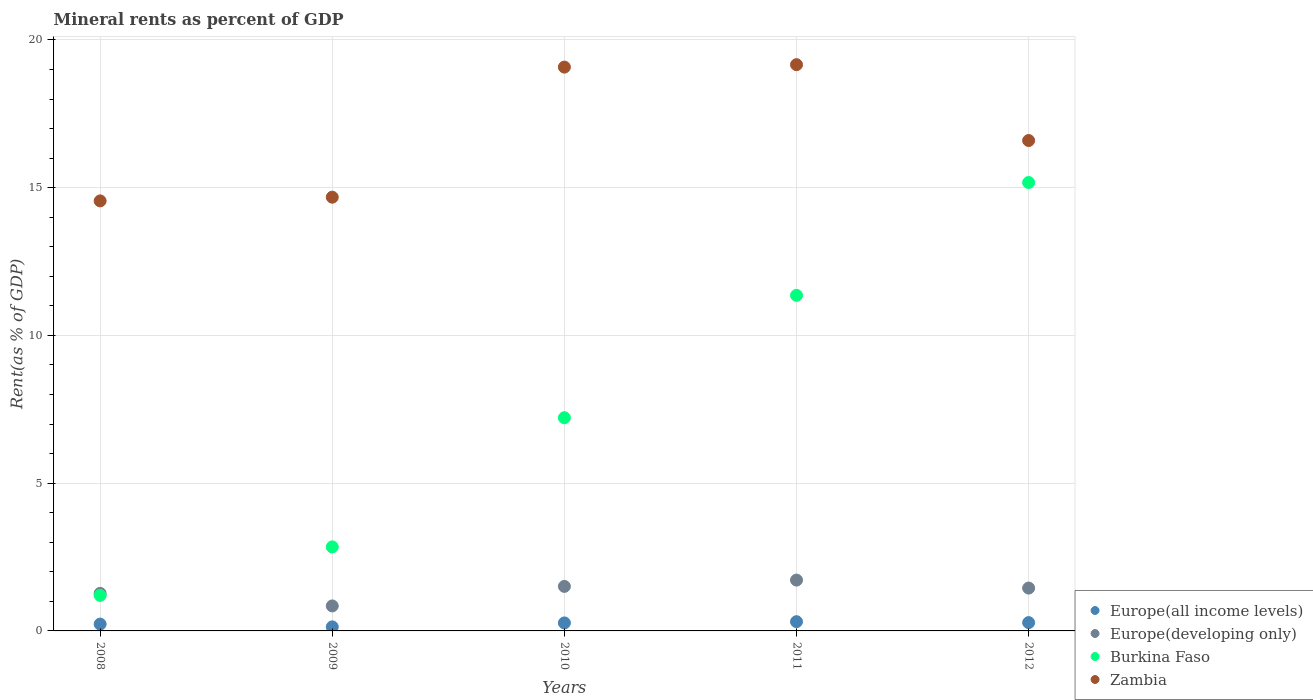How many different coloured dotlines are there?
Offer a very short reply. 4. Is the number of dotlines equal to the number of legend labels?
Make the answer very short. Yes. What is the mineral rent in Europe(all income levels) in 2012?
Ensure brevity in your answer.  0.28. Across all years, what is the maximum mineral rent in Europe(all income levels)?
Give a very brief answer. 0.31. Across all years, what is the minimum mineral rent in Zambia?
Keep it short and to the point. 14.55. What is the total mineral rent in Burkina Faso in the graph?
Provide a short and direct response. 37.79. What is the difference between the mineral rent in Europe(all income levels) in 2009 and that in 2011?
Provide a short and direct response. -0.17. What is the difference between the mineral rent in Europe(developing only) in 2012 and the mineral rent in Zambia in 2008?
Offer a terse response. -13.1. What is the average mineral rent in Zambia per year?
Give a very brief answer. 16.81. In the year 2010, what is the difference between the mineral rent in Europe(all income levels) and mineral rent in Burkina Faso?
Provide a short and direct response. -6.94. What is the ratio of the mineral rent in Europe(all income levels) in 2008 to that in 2010?
Provide a short and direct response. 0.86. Is the difference between the mineral rent in Europe(all income levels) in 2008 and 2012 greater than the difference between the mineral rent in Burkina Faso in 2008 and 2012?
Provide a succinct answer. Yes. What is the difference between the highest and the second highest mineral rent in Zambia?
Offer a very short reply. 0.08. What is the difference between the highest and the lowest mineral rent in Burkina Faso?
Keep it short and to the point. 13.97. Does the mineral rent in Europe(all income levels) monotonically increase over the years?
Your answer should be compact. No. Is the mineral rent in Europe(all income levels) strictly less than the mineral rent in Burkina Faso over the years?
Make the answer very short. Yes. Are the values on the major ticks of Y-axis written in scientific E-notation?
Provide a short and direct response. No. Does the graph contain any zero values?
Your answer should be very brief. No. Does the graph contain grids?
Offer a very short reply. Yes. What is the title of the graph?
Ensure brevity in your answer.  Mineral rents as percent of GDP. What is the label or title of the Y-axis?
Provide a short and direct response. Rent(as % of GDP). What is the Rent(as % of GDP) in Europe(all income levels) in 2008?
Keep it short and to the point. 0.23. What is the Rent(as % of GDP) in Europe(developing only) in 2008?
Your answer should be very brief. 1.27. What is the Rent(as % of GDP) of Burkina Faso in 2008?
Give a very brief answer. 1.2. What is the Rent(as % of GDP) in Zambia in 2008?
Your answer should be very brief. 14.55. What is the Rent(as % of GDP) of Europe(all income levels) in 2009?
Provide a succinct answer. 0.14. What is the Rent(as % of GDP) of Europe(developing only) in 2009?
Provide a succinct answer. 0.85. What is the Rent(as % of GDP) in Burkina Faso in 2009?
Your response must be concise. 2.84. What is the Rent(as % of GDP) of Zambia in 2009?
Offer a terse response. 14.68. What is the Rent(as % of GDP) in Europe(all income levels) in 2010?
Ensure brevity in your answer.  0.27. What is the Rent(as % of GDP) of Europe(developing only) in 2010?
Provide a short and direct response. 1.51. What is the Rent(as % of GDP) of Burkina Faso in 2010?
Make the answer very short. 7.22. What is the Rent(as % of GDP) in Zambia in 2010?
Offer a very short reply. 19.08. What is the Rent(as % of GDP) of Europe(all income levels) in 2011?
Your answer should be very brief. 0.31. What is the Rent(as % of GDP) of Europe(developing only) in 2011?
Offer a very short reply. 1.72. What is the Rent(as % of GDP) in Burkina Faso in 2011?
Make the answer very short. 11.36. What is the Rent(as % of GDP) of Zambia in 2011?
Provide a succinct answer. 19.16. What is the Rent(as % of GDP) in Europe(all income levels) in 2012?
Keep it short and to the point. 0.28. What is the Rent(as % of GDP) in Europe(developing only) in 2012?
Your answer should be very brief. 1.45. What is the Rent(as % of GDP) of Burkina Faso in 2012?
Offer a terse response. 15.18. What is the Rent(as % of GDP) in Zambia in 2012?
Offer a very short reply. 16.6. Across all years, what is the maximum Rent(as % of GDP) of Europe(all income levels)?
Your answer should be very brief. 0.31. Across all years, what is the maximum Rent(as % of GDP) in Europe(developing only)?
Ensure brevity in your answer.  1.72. Across all years, what is the maximum Rent(as % of GDP) of Burkina Faso?
Keep it short and to the point. 15.18. Across all years, what is the maximum Rent(as % of GDP) in Zambia?
Provide a succinct answer. 19.16. Across all years, what is the minimum Rent(as % of GDP) in Europe(all income levels)?
Offer a terse response. 0.14. Across all years, what is the minimum Rent(as % of GDP) of Europe(developing only)?
Your answer should be compact. 0.85. Across all years, what is the minimum Rent(as % of GDP) of Burkina Faso?
Provide a short and direct response. 1.2. Across all years, what is the minimum Rent(as % of GDP) of Zambia?
Provide a short and direct response. 14.55. What is the total Rent(as % of GDP) in Europe(all income levels) in the graph?
Offer a very short reply. 1.23. What is the total Rent(as % of GDP) of Europe(developing only) in the graph?
Offer a very short reply. 6.79. What is the total Rent(as % of GDP) of Burkina Faso in the graph?
Provide a succinct answer. 37.79. What is the total Rent(as % of GDP) of Zambia in the graph?
Offer a terse response. 84.07. What is the difference between the Rent(as % of GDP) of Europe(all income levels) in 2008 and that in 2009?
Keep it short and to the point. 0.09. What is the difference between the Rent(as % of GDP) of Europe(developing only) in 2008 and that in 2009?
Your response must be concise. 0.42. What is the difference between the Rent(as % of GDP) of Burkina Faso in 2008 and that in 2009?
Your answer should be compact. -1.64. What is the difference between the Rent(as % of GDP) in Zambia in 2008 and that in 2009?
Give a very brief answer. -0.13. What is the difference between the Rent(as % of GDP) of Europe(all income levels) in 2008 and that in 2010?
Offer a terse response. -0.04. What is the difference between the Rent(as % of GDP) of Europe(developing only) in 2008 and that in 2010?
Ensure brevity in your answer.  -0.24. What is the difference between the Rent(as % of GDP) of Burkina Faso in 2008 and that in 2010?
Ensure brevity in your answer.  -6.01. What is the difference between the Rent(as % of GDP) in Zambia in 2008 and that in 2010?
Offer a very short reply. -4.53. What is the difference between the Rent(as % of GDP) in Europe(all income levels) in 2008 and that in 2011?
Provide a succinct answer. -0.08. What is the difference between the Rent(as % of GDP) in Europe(developing only) in 2008 and that in 2011?
Your response must be concise. -0.45. What is the difference between the Rent(as % of GDP) of Burkina Faso in 2008 and that in 2011?
Offer a terse response. -10.15. What is the difference between the Rent(as % of GDP) of Zambia in 2008 and that in 2011?
Offer a very short reply. -4.61. What is the difference between the Rent(as % of GDP) of Europe(all income levels) in 2008 and that in 2012?
Offer a very short reply. -0.05. What is the difference between the Rent(as % of GDP) of Europe(developing only) in 2008 and that in 2012?
Ensure brevity in your answer.  -0.18. What is the difference between the Rent(as % of GDP) of Burkina Faso in 2008 and that in 2012?
Make the answer very short. -13.97. What is the difference between the Rent(as % of GDP) of Zambia in 2008 and that in 2012?
Offer a terse response. -2.04. What is the difference between the Rent(as % of GDP) in Europe(all income levels) in 2009 and that in 2010?
Offer a terse response. -0.13. What is the difference between the Rent(as % of GDP) of Europe(developing only) in 2009 and that in 2010?
Give a very brief answer. -0.66. What is the difference between the Rent(as % of GDP) of Burkina Faso in 2009 and that in 2010?
Keep it short and to the point. -4.37. What is the difference between the Rent(as % of GDP) of Zambia in 2009 and that in 2010?
Your answer should be very brief. -4.4. What is the difference between the Rent(as % of GDP) of Europe(all income levels) in 2009 and that in 2011?
Offer a very short reply. -0.17. What is the difference between the Rent(as % of GDP) in Europe(developing only) in 2009 and that in 2011?
Your response must be concise. -0.87. What is the difference between the Rent(as % of GDP) of Burkina Faso in 2009 and that in 2011?
Make the answer very short. -8.51. What is the difference between the Rent(as % of GDP) in Zambia in 2009 and that in 2011?
Keep it short and to the point. -4.48. What is the difference between the Rent(as % of GDP) of Europe(all income levels) in 2009 and that in 2012?
Keep it short and to the point. -0.14. What is the difference between the Rent(as % of GDP) of Europe(developing only) in 2009 and that in 2012?
Offer a terse response. -0.6. What is the difference between the Rent(as % of GDP) in Burkina Faso in 2009 and that in 2012?
Give a very brief answer. -12.33. What is the difference between the Rent(as % of GDP) in Zambia in 2009 and that in 2012?
Offer a terse response. -1.92. What is the difference between the Rent(as % of GDP) in Europe(all income levels) in 2010 and that in 2011?
Offer a very short reply. -0.04. What is the difference between the Rent(as % of GDP) in Europe(developing only) in 2010 and that in 2011?
Ensure brevity in your answer.  -0.21. What is the difference between the Rent(as % of GDP) of Burkina Faso in 2010 and that in 2011?
Ensure brevity in your answer.  -4.14. What is the difference between the Rent(as % of GDP) of Zambia in 2010 and that in 2011?
Your response must be concise. -0.08. What is the difference between the Rent(as % of GDP) of Europe(all income levels) in 2010 and that in 2012?
Give a very brief answer. -0.01. What is the difference between the Rent(as % of GDP) in Europe(developing only) in 2010 and that in 2012?
Your response must be concise. 0.06. What is the difference between the Rent(as % of GDP) in Burkina Faso in 2010 and that in 2012?
Provide a short and direct response. -7.96. What is the difference between the Rent(as % of GDP) of Zambia in 2010 and that in 2012?
Your response must be concise. 2.48. What is the difference between the Rent(as % of GDP) of Europe(all income levels) in 2011 and that in 2012?
Give a very brief answer. 0.03. What is the difference between the Rent(as % of GDP) in Europe(developing only) in 2011 and that in 2012?
Ensure brevity in your answer.  0.27. What is the difference between the Rent(as % of GDP) of Burkina Faso in 2011 and that in 2012?
Your response must be concise. -3.82. What is the difference between the Rent(as % of GDP) in Zambia in 2011 and that in 2012?
Offer a terse response. 2.57. What is the difference between the Rent(as % of GDP) of Europe(all income levels) in 2008 and the Rent(as % of GDP) of Europe(developing only) in 2009?
Offer a very short reply. -0.61. What is the difference between the Rent(as % of GDP) in Europe(all income levels) in 2008 and the Rent(as % of GDP) in Burkina Faso in 2009?
Keep it short and to the point. -2.61. What is the difference between the Rent(as % of GDP) in Europe(all income levels) in 2008 and the Rent(as % of GDP) in Zambia in 2009?
Offer a very short reply. -14.45. What is the difference between the Rent(as % of GDP) in Europe(developing only) in 2008 and the Rent(as % of GDP) in Burkina Faso in 2009?
Your answer should be very brief. -1.57. What is the difference between the Rent(as % of GDP) of Europe(developing only) in 2008 and the Rent(as % of GDP) of Zambia in 2009?
Your answer should be compact. -13.41. What is the difference between the Rent(as % of GDP) of Burkina Faso in 2008 and the Rent(as % of GDP) of Zambia in 2009?
Keep it short and to the point. -13.48. What is the difference between the Rent(as % of GDP) in Europe(all income levels) in 2008 and the Rent(as % of GDP) in Europe(developing only) in 2010?
Provide a succinct answer. -1.28. What is the difference between the Rent(as % of GDP) of Europe(all income levels) in 2008 and the Rent(as % of GDP) of Burkina Faso in 2010?
Make the answer very short. -6.98. What is the difference between the Rent(as % of GDP) in Europe(all income levels) in 2008 and the Rent(as % of GDP) in Zambia in 2010?
Your response must be concise. -18.85. What is the difference between the Rent(as % of GDP) of Europe(developing only) in 2008 and the Rent(as % of GDP) of Burkina Faso in 2010?
Keep it short and to the point. -5.94. What is the difference between the Rent(as % of GDP) in Europe(developing only) in 2008 and the Rent(as % of GDP) in Zambia in 2010?
Make the answer very short. -17.81. What is the difference between the Rent(as % of GDP) in Burkina Faso in 2008 and the Rent(as % of GDP) in Zambia in 2010?
Ensure brevity in your answer.  -17.88. What is the difference between the Rent(as % of GDP) in Europe(all income levels) in 2008 and the Rent(as % of GDP) in Europe(developing only) in 2011?
Make the answer very short. -1.49. What is the difference between the Rent(as % of GDP) of Europe(all income levels) in 2008 and the Rent(as % of GDP) of Burkina Faso in 2011?
Ensure brevity in your answer.  -11.13. What is the difference between the Rent(as % of GDP) in Europe(all income levels) in 2008 and the Rent(as % of GDP) in Zambia in 2011?
Offer a terse response. -18.93. What is the difference between the Rent(as % of GDP) in Europe(developing only) in 2008 and the Rent(as % of GDP) in Burkina Faso in 2011?
Your answer should be very brief. -10.09. What is the difference between the Rent(as % of GDP) in Europe(developing only) in 2008 and the Rent(as % of GDP) in Zambia in 2011?
Your response must be concise. -17.89. What is the difference between the Rent(as % of GDP) in Burkina Faso in 2008 and the Rent(as % of GDP) in Zambia in 2011?
Your answer should be very brief. -17.96. What is the difference between the Rent(as % of GDP) in Europe(all income levels) in 2008 and the Rent(as % of GDP) in Europe(developing only) in 2012?
Your answer should be compact. -1.22. What is the difference between the Rent(as % of GDP) in Europe(all income levels) in 2008 and the Rent(as % of GDP) in Burkina Faso in 2012?
Provide a short and direct response. -14.94. What is the difference between the Rent(as % of GDP) in Europe(all income levels) in 2008 and the Rent(as % of GDP) in Zambia in 2012?
Your response must be concise. -16.36. What is the difference between the Rent(as % of GDP) of Europe(developing only) in 2008 and the Rent(as % of GDP) of Burkina Faso in 2012?
Offer a terse response. -13.9. What is the difference between the Rent(as % of GDP) in Europe(developing only) in 2008 and the Rent(as % of GDP) in Zambia in 2012?
Your response must be concise. -15.33. What is the difference between the Rent(as % of GDP) in Burkina Faso in 2008 and the Rent(as % of GDP) in Zambia in 2012?
Make the answer very short. -15.39. What is the difference between the Rent(as % of GDP) of Europe(all income levels) in 2009 and the Rent(as % of GDP) of Europe(developing only) in 2010?
Provide a short and direct response. -1.37. What is the difference between the Rent(as % of GDP) in Europe(all income levels) in 2009 and the Rent(as % of GDP) in Burkina Faso in 2010?
Your answer should be compact. -7.08. What is the difference between the Rent(as % of GDP) of Europe(all income levels) in 2009 and the Rent(as % of GDP) of Zambia in 2010?
Your answer should be very brief. -18.94. What is the difference between the Rent(as % of GDP) in Europe(developing only) in 2009 and the Rent(as % of GDP) in Burkina Faso in 2010?
Give a very brief answer. -6.37. What is the difference between the Rent(as % of GDP) of Europe(developing only) in 2009 and the Rent(as % of GDP) of Zambia in 2010?
Your answer should be very brief. -18.24. What is the difference between the Rent(as % of GDP) in Burkina Faso in 2009 and the Rent(as % of GDP) in Zambia in 2010?
Provide a short and direct response. -16.24. What is the difference between the Rent(as % of GDP) of Europe(all income levels) in 2009 and the Rent(as % of GDP) of Europe(developing only) in 2011?
Keep it short and to the point. -1.58. What is the difference between the Rent(as % of GDP) in Europe(all income levels) in 2009 and the Rent(as % of GDP) in Burkina Faso in 2011?
Your answer should be very brief. -11.22. What is the difference between the Rent(as % of GDP) of Europe(all income levels) in 2009 and the Rent(as % of GDP) of Zambia in 2011?
Your answer should be compact. -19.03. What is the difference between the Rent(as % of GDP) in Europe(developing only) in 2009 and the Rent(as % of GDP) in Burkina Faso in 2011?
Ensure brevity in your answer.  -10.51. What is the difference between the Rent(as % of GDP) in Europe(developing only) in 2009 and the Rent(as % of GDP) in Zambia in 2011?
Offer a very short reply. -18.32. What is the difference between the Rent(as % of GDP) in Burkina Faso in 2009 and the Rent(as % of GDP) in Zambia in 2011?
Ensure brevity in your answer.  -16.32. What is the difference between the Rent(as % of GDP) in Europe(all income levels) in 2009 and the Rent(as % of GDP) in Europe(developing only) in 2012?
Offer a very short reply. -1.31. What is the difference between the Rent(as % of GDP) in Europe(all income levels) in 2009 and the Rent(as % of GDP) in Burkina Faso in 2012?
Keep it short and to the point. -15.04. What is the difference between the Rent(as % of GDP) of Europe(all income levels) in 2009 and the Rent(as % of GDP) of Zambia in 2012?
Offer a very short reply. -16.46. What is the difference between the Rent(as % of GDP) of Europe(developing only) in 2009 and the Rent(as % of GDP) of Burkina Faso in 2012?
Your answer should be compact. -14.33. What is the difference between the Rent(as % of GDP) of Europe(developing only) in 2009 and the Rent(as % of GDP) of Zambia in 2012?
Your response must be concise. -15.75. What is the difference between the Rent(as % of GDP) in Burkina Faso in 2009 and the Rent(as % of GDP) in Zambia in 2012?
Provide a succinct answer. -13.75. What is the difference between the Rent(as % of GDP) in Europe(all income levels) in 2010 and the Rent(as % of GDP) in Europe(developing only) in 2011?
Your response must be concise. -1.45. What is the difference between the Rent(as % of GDP) of Europe(all income levels) in 2010 and the Rent(as % of GDP) of Burkina Faso in 2011?
Keep it short and to the point. -11.09. What is the difference between the Rent(as % of GDP) in Europe(all income levels) in 2010 and the Rent(as % of GDP) in Zambia in 2011?
Provide a succinct answer. -18.89. What is the difference between the Rent(as % of GDP) in Europe(developing only) in 2010 and the Rent(as % of GDP) in Burkina Faso in 2011?
Your answer should be very brief. -9.85. What is the difference between the Rent(as % of GDP) of Europe(developing only) in 2010 and the Rent(as % of GDP) of Zambia in 2011?
Provide a succinct answer. -17.66. What is the difference between the Rent(as % of GDP) in Burkina Faso in 2010 and the Rent(as % of GDP) in Zambia in 2011?
Offer a very short reply. -11.95. What is the difference between the Rent(as % of GDP) of Europe(all income levels) in 2010 and the Rent(as % of GDP) of Europe(developing only) in 2012?
Give a very brief answer. -1.18. What is the difference between the Rent(as % of GDP) of Europe(all income levels) in 2010 and the Rent(as % of GDP) of Burkina Faso in 2012?
Your answer should be very brief. -14.9. What is the difference between the Rent(as % of GDP) of Europe(all income levels) in 2010 and the Rent(as % of GDP) of Zambia in 2012?
Keep it short and to the point. -16.33. What is the difference between the Rent(as % of GDP) in Europe(developing only) in 2010 and the Rent(as % of GDP) in Burkina Faso in 2012?
Your answer should be compact. -13.67. What is the difference between the Rent(as % of GDP) of Europe(developing only) in 2010 and the Rent(as % of GDP) of Zambia in 2012?
Offer a terse response. -15.09. What is the difference between the Rent(as % of GDP) in Burkina Faso in 2010 and the Rent(as % of GDP) in Zambia in 2012?
Ensure brevity in your answer.  -9.38. What is the difference between the Rent(as % of GDP) of Europe(all income levels) in 2011 and the Rent(as % of GDP) of Europe(developing only) in 2012?
Make the answer very short. -1.14. What is the difference between the Rent(as % of GDP) in Europe(all income levels) in 2011 and the Rent(as % of GDP) in Burkina Faso in 2012?
Give a very brief answer. -14.86. What is the difference between the Rent(as % of GDP) of Europe(all income levels) in 2011 and the Rent(as % of GDP) of Zambia in 2012?
Provide a succinct answer. -16.28. What is the difference between the Rent(as % of GDP) of Europe(developing only) in 2011 and the Rent(as % of GDP) of Burkina Faso in 2012?
Ensure brevity in your answer.  -13.45. What is the difference between the Rent(as % of GDP) in Europe(developing only) in 2011 and the Rent(as % of GDP) in Zambia in 2012?
Your answer should be compact. -14.88. What is the difference between the Rent(as % of GDP) of Burkina Faso in 2011 and the Rent(as % of GDP) of Zambia in 2012?
Your response must be concise. -5.24. What is the average Rent(as % of GDP) of Europe(all income levels) per year?
Keep it short and to the point. 0.25. What is the average Rent(as % of GDP) of Europe(developing only) per year?
Ensure brevity in your answer.  1.36. What is the average Rent(as % of GDP) in Burkina Faso per year?
Your answer should be very brief. 7.56. What is the average Rent(as % of GDP) in Zambia per year?
Provide a short and direct response. 16.81. In the year 2008, what is the difference between the Rent(as % of GDP) in Europe(all income levels) and Rent(as % of GDP) in Europe(developing only)?
Provide a short and direct response. -1.04. In the year 2008, what is the difference between the Rent(as % of GDP) in Europe(all income levels) and Rent(as % of GDP) in Burkina Faso?
Your answer should be very brief. -0.97. In the year 2008, what is the difference between the Rent(as % of GDP) in Europe(all income levels) and Rent(as % of GDP) in Zambia?
Make the answer very short. -14.32. In the year 2008, what is the difference between the Rent(as % of GDP) in Europe(developing only) and Rent(as % of GDP) in Burkina Faso?
Ensure brevity in your answer.  0.07. In the year 2008, what is the difference between the Rent(as % of GDP) of Europe(developing only) and Rent(as % of GDP) of Zambia?
Offer a terse response. -13.28. In the year 2008, what is the difference between the Rent(as % of GDP) in Burkina Faso and Rent(as % of GDP) in Zambia?
Your response must be concise. -13.35. In the year 2009, what is the difference between the Rent(as % of GDP) in Europe(all income levels) and Rent(as % of GDP) in Europe(developing only)?
Your answer should be very brief. -0.71. In the year 2009, what is the difference between the Rent(as % of GDP) in Europe(all income levels) and Rent(as % of GDP) in Burkina Faso?
Your answer should be very brief. -2.71. In the year 2009, what is the difference between the Rent(as % of GDP) of Europe(all income levels) and Rent(as % of GDP) of Zambia?
Offer a terse response. -14.54. In the year 2009, what is the difference between the Rent(as % of GDP) in Europe(developing only) and Rent(as % of GDP) in Burkina Faso?
Keep it short and to the point. -2. In the year 2009, what is the difference between the Rent(as % of GDP) of Europe(developing only) and Rent(as % of GDP) of Zambia?
Your answer should be very brief. -13.83. In the year 2009, what is the difference between the Rent(as % of GDP) of Burkina Faso and Rent(as % of GDP) of Zambia?
Provide a short and direct response. -11.83. In the year 2010, what is the difference between the Rent(as % of GDP) in Europe(all income levels) and Rent(as % of GDP) in Europe(developing only)?
Your response must be concise. -1.24. In the year 2010, what is the difference between the Rent(as % of GDP) in Europe(all income levels) and Rent(as % of GDP) in Burkina Faso?
Your answer should be compact. -6.94. In the year 2010, what is the difference between the Rent(as % of GDP) of Europe(all income levels) and Rent(as % of GDP) of Zambia?
Give a very brief answer. -18.81. In the year 2010, what is the difference between the Rent(as % of GDP) of Europe(developing only) and Rent(as % of GDP) of Burkina Faso?
Keep it short and to the point. -5.71. In the year 2010, what is the difference between the Rent(as % of GDP) of Europe(developing only) and Rent(as % of GDP) of Zambia?
Ensure brevity in your answer.  -17.57. In the year 2010, what is the difference between the Rent(as % of GDP) of Burkina Faso and Rent(as % of GDP) of Zambia?
Give a very brief answer. -11.87. In the year 2011, what is the difference between the Rent(as % of GDP) of Europe(all income levels) and Rent(as % of GDP) of Europe(developing only)?
Your response must be concise. -1.41. In the year 2011, what is the difference between the Rent(as % of GDP) of Europe(all income levels) and Rent(as % of GDP) of Burkina Faso?
Keep it short and to the point. -11.04. In the year 2011, what is the difference between the Rent(as % of GDP) of Europe(all income levels) and Rent(as % of GDP) of Zambia?
Your response must be concise. -18.85. In the year 2011, what is the difference between the Rent(as % of GDP) in Europe(developing only) and Rent(as % of GDP) in Burkina Faso?
Offer a very short reply. -9.64. In the year 2011, what is the difference between the Rent(as % of GDP) of Europe(developing only) and Rent(as % of GDP) of Zambia?
Ensure brevity in your answer.  -17.44. In the year 2011, what is the difference between the Rent(as % of GDP) in Burkina Faso and Rent(as % of GDP) in Zambia?
Keep it short and to the point. -7.81. In the year 2012, what is the difference between the Rent(as % of GDP) in Europe(all income levels) and Rent(as % of GDP) in Europe(developing only)?
Keep it short and to the point. -1.17. In the year 2012, what is the difference between the Rent(as % of GDP) of Europe(all income levels) and Rent(as % of GDP) of Burkina Faso?
Provide a short and direct response. -14.89. In the year 2012, what is the difference between the Rent(as % of GDP) in Europe(all income levels) and Rent(as % of GDP) in Zambia?
Make the answer very short. -16.32. In the year 2012, what is the difference between the Rent(as % of GDP) in Europe(developing only) and Rent(as % of GDP) in Burkina Faso?
Provide a succinct answer. -13.73. In the year 2012, what is the difference between the Rent(as % of GDP) in Europe(developing only) and Rent(as % of GDP) in Zambia?
Give a very brief answer. -15.15. In the year 2012, what is the difference between the Rent(as % of GDP) in Burkina Faso and Rent(as % of GDP) in Zambia?
Your answer should be compact. -1.42. What is the ratio of the Rent(as % of GDP) of Europe(all income levels) in 2008 to that in 2009?
Provide a short and direct response. 1.68. What is the ratio of the Rent(as % of GDP) in Europe(developing only) in 2008 to that in 2009?
Your answer should be compact. 1.5. What is the ratio of the Rent(as % of GDP) in Burkina Faso in 2008 to that in 2009?
Your answer should be very brief. 0.42. What is the ratio of the Rent(as % of GDP) of Europe(all income levels) in 2008 to that in 2010?
Offer a very short reply. 0.86. What is the ratio of the Rent(as % of GDP) of Europe(developing only) in 2008 to that in 2010?
Your answer should be very brief. 0.84. What is the ratio of the Rent(as % of GDP) of Zambia in 2008 to that in 2010?
Your response must be concise. 0.76. What is the ratio of the Rent(as % of GDP) in Europe(all income levels) in 2008 to that in 2011?
Offer a very short reply. 0.74. What is the ratio of the Rent(as % of GDP) in Europe(developing only) in 2008 to that in 2011?
Offer a terse response. 0.74. What is the ratio of the Rent(as % of GDP) in Burkina Faso in 2008 to that in 2011?
Your response must be concise. 0.11. What is the ratio of the Rent(as % of GDP) of Zambia in 2008 to that in 2011?
Your answer should be compact. 0.76. What is the ratio of the Rent(as % of GDP) of Europe(all income levels) in 2008 to that in 2012?
Give a very brief answer. 0.82. What is the ratio of the Rent(as % of GDP) of Europe(developing only) in 2008 to that in 2012?
Your response must be concise. 0.88. What is the ratio of the Rent(as % of GDP) in Burkina Faso in 2008 to that in 2012?
Your answer should be very brief. 0.08. What is the ratio of the Rent(as % of GDP) of Zambia in 2008 to that in 2012?
Provide a succinct answer. 0.88. What is the ratio of the Rent(as % of GDP) of Europe(all income levels) in 2009 to that in 2010?
Give a very brief answer. 0.51. What is the ratio of the Rent(as % of GDP) of Europe(developing only) in 2009 to that in 2010?
Provide a succinct answer. 0.56. What is the ratio of the Rent(as % of GDP) of Burkina Faso in 2009 to that in 2010?
Offer a terse response. 0.39. What is the ratio of the Rent(as % of GDP) of Zambia in 2009 to that in 2010?
Your answer should be compact. 0.77. What is the ratio of the Rent(as % of GDP) of Europe(all income levels) in 2009 to that in 2011?
Your answer should be compact. 0.44. What is the ratio of the Rent(as % of GDP) of Europe(developing only) in 2009 to that in 2011?
Provide a short and direct response. 0.49. What is the ratio of the Rent(as % of GDP) in Burkina Faso in 2009 to that in 2011?
Offer a very short reply. 0.25. What is the ratio of the Rent(as % of GDP) in Zambia in 2009 to that in 2011?
Ensure brevity in your answer.  0.77. What is the ratio of the Rent(as % of GDP) in Europe(all income levels) in 2009 to that in 2012?
Ensure brevity in your answer.  0.49. What is the ratio of the Rent(as % of GDP) in Europe(developing only) in 2009 to that in 2012?
Your answer should be compact. 0.58. What is the ratio of the Rent(as % of GDP) in Burkina Faso in 2009 to that in 2012?
Provide a short and direct response. 0.19. What is the ratio of the Rent(as % of GDP) in Zambia in 2009 to that in 2012?
Provide a succinct answer. 0.88. What is the ratio of the Rent(as % of GDP) in Europe(all income levels) in 2010 to that in 2011?
Provide a succinct answer. 0.87. What is the ratio of the Rent(as % of GDP) of Europe(developing only) in 2010 to that in 2011?
Offer a terse response. 0.88. What is the ratio of the Rent(as % of GDP) in Burkina Faso in 2010 to that in 2011?
Offer a very short reply. 0.64. What is the ratio of the Rent(as % of GDP) of Zambia in 2010 to that in 2011?
Your response must be concise. 1. What is the ratio of the Rent(as % of GDP) in Europe(all income levels) in 2010 to that in 2012?
Keep it short and to the point. 0.96. What is the ratio of the Rent(as % of GDP) in Europe(developing only) in 2010 to that in 2012?
Provide a succinct answer. 1.04. What is the ratio of the Rent(as % of GDP) in Burkina Faso in 2010 to that in 2012?
Your answer should be very brief. 0.48. What is the ratio of the Rent(as % of GDP) in Zambia in 2010 to that in 2012?
Give a very brief answer. 1.15. What is the ratio of the Rent(as % of GDP) of Europe(all income levels) in 2011 to that in 2012?
Provide a succinct answer. 1.11. What is the ratio of the Rent(as % of GDP) in Europe(developing only) in 2011 to that in 2012?
Provide a short and direct response. 1.19. What is the ratio of the Rent(as % of GDP) in Burkina Faso in 2011 to that in 2012?
Your response must be concise. 0.75. What is the ratio of the Rent(as % of GDP) of Zambia in 2011 to that in 2012?
Your response must be concise. 1.15. What is the difference between the highest and the second highest Rent(as % of GDP) in Europe(all income levels)?
Ensure brevity in your answer.  0.03. What is the difference between the highest and the second highest Rent(as % of GDP) in Europe(developing only)?
Ensure brevity in your answer.  0.21. What is the difference between the highest and the second highest Rent(as % of GDP) of Burkina Faso?
Your answer should be very brief. 3.82. What is the difference between the highest and the second highest Rent(as % of GDP) in Zambia?
Make the answer very short. 0.08. What is the difference between the highest and the lowest Rent(as % of GDP) of Europe(all income levels)?
Your answer should be compact. 0.17. What is the difference between the highest and the lowest Rent(as % of GDP) of Europe(developing only)?
Ensure brevity in your answer.  0.87. What is the difference between the highest and the lowest Rent(as % of GDP) of Burkina Faso?
Keep it short and to the point. 13.97. What is the difference between the highest and the lowest Rent(as % of GDP) of Zambia?
Provide a succinct answer. 4.61. 